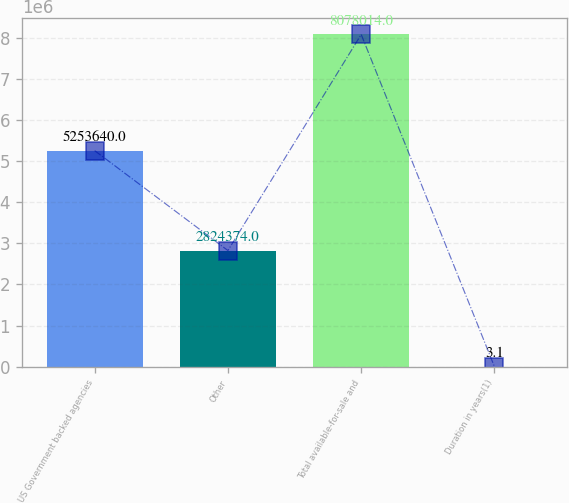<chart> <loc_0><loc_0><loc_500><loc_500><bar_chart><fcel>US Government backed agencies<fcel>Other<fcel>Total available-for-sale and<fcel>Duration in years(1)<nl><fcel>5.25364e+06<fcel>2.82437e+06<fcel>8.07801e+06<fcel>3.1<nl></chart> 